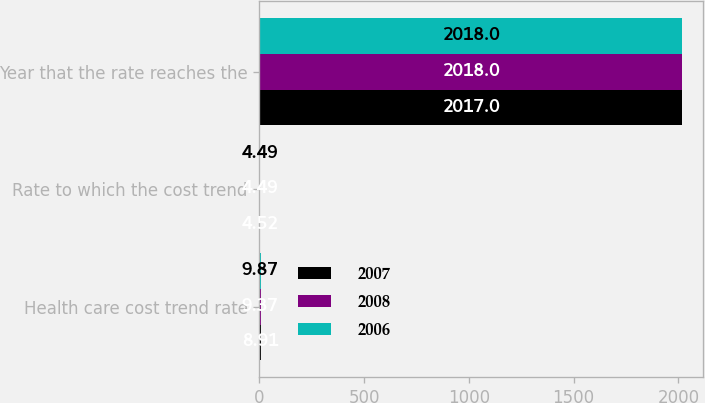<chart> <loc_0><loc_0><loc_500><loc_500><stacked_bar_chart><ecel><fcel>Health care cost trend rate<fcel>Rate to which the cost trend<fcel>Year that the rate reaches the<nl><fcel>2007<fcel>8.91<fcel>4.52<fcel>2017<nl><fcel>2008<fcel>9.37<fcel>4.49<fcel>2018<nl><fcel>2006<fcel>9.87<fcel>4.49<fcel>2018<nl></chart> 